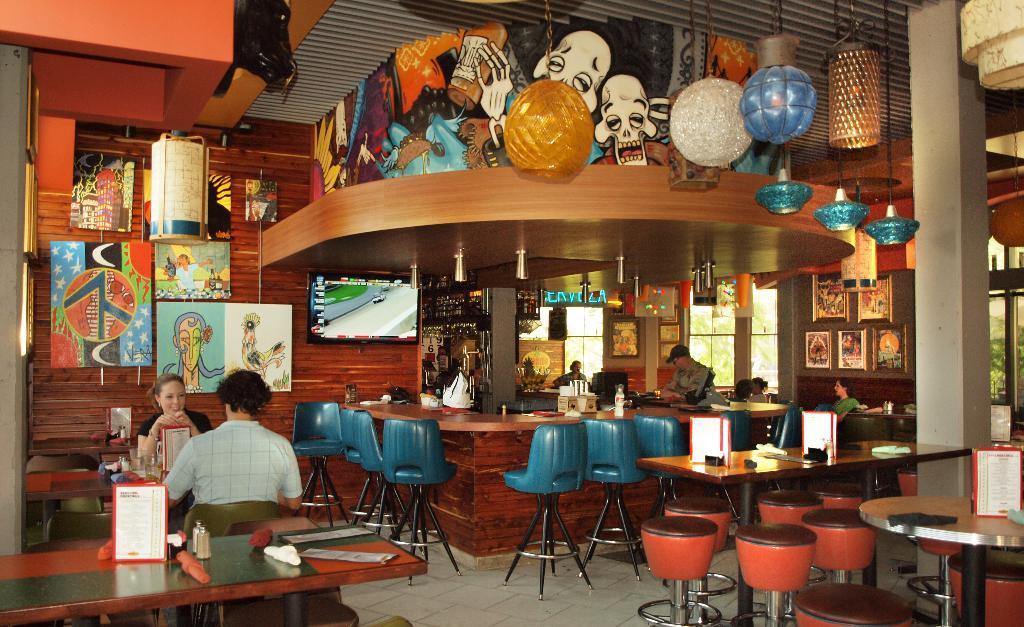Can you describe this image briefly? It's a picture of a cafe. On the left side there is a women who is smiling, in front of here there is another person who is sitting on a chair. On right side there are four persons. We can see on the walls, there are photo frames here and here. On the top we see a cartoons. In this room there are so many table and chairs. Here it's a window. There is a bottle on the L-shaped desk. 